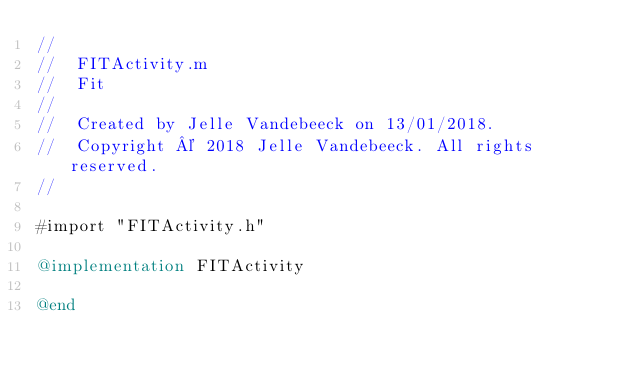<code> <loc_0><loc_0><loc_500><loc_500><_ObjectiveC_>//
//  FITActivity.m
//  Fit
//
//  Created by Jelle Vandebeeck on 13/01/2018.
//  Copyright © 2018 Jelle Vandebeeck. All rights reserved.
//

#import "FITActivity.h"

@implementation FITActivity

@end
</code> 